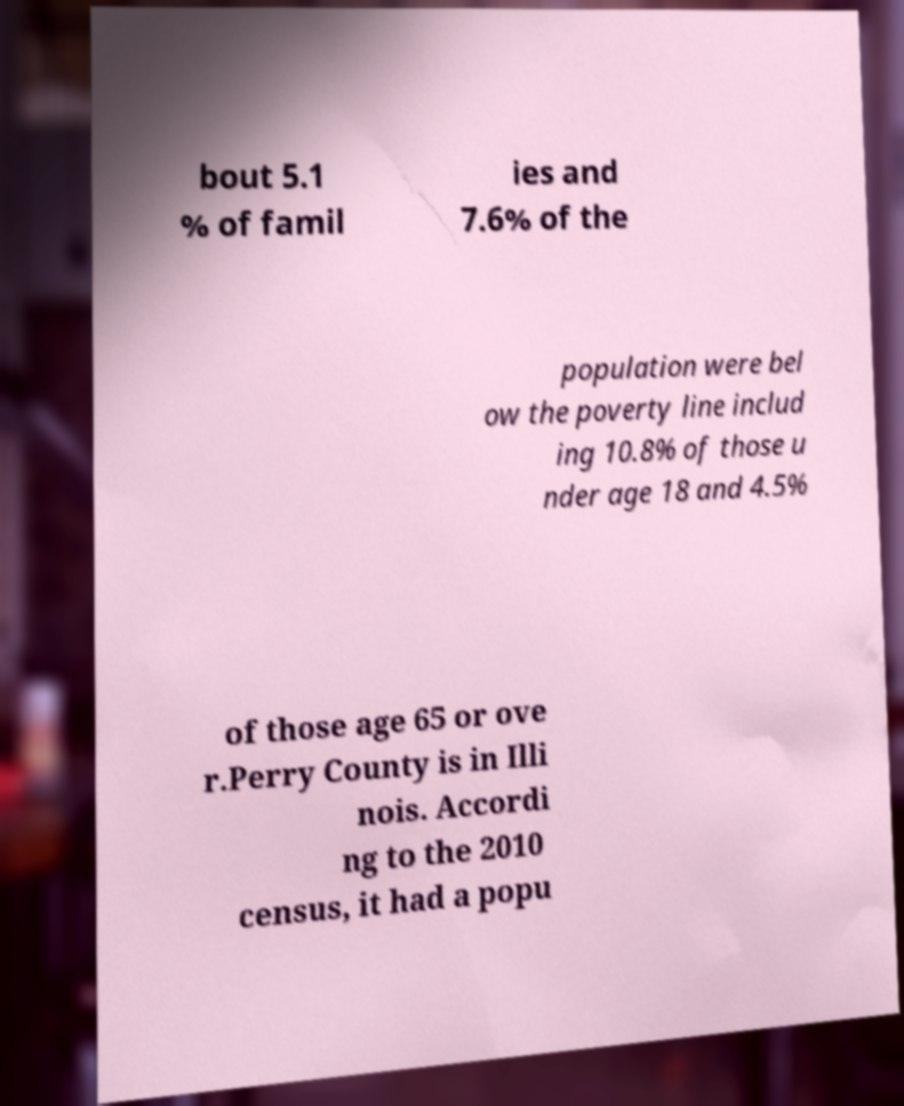Can you read and provide the text displayed in the image?This photo seems to have some interesting text. Can you extract and type it out for me? bout 5.1 % of famil ies and 7.6% of the population were bel ow the poverty line includ ing 10.8% of those u nder age 18 and 4.5% of those age 65 or ove r.Perry County is in Illi nois. Accordi ng to the 2010 census, it had a popu 